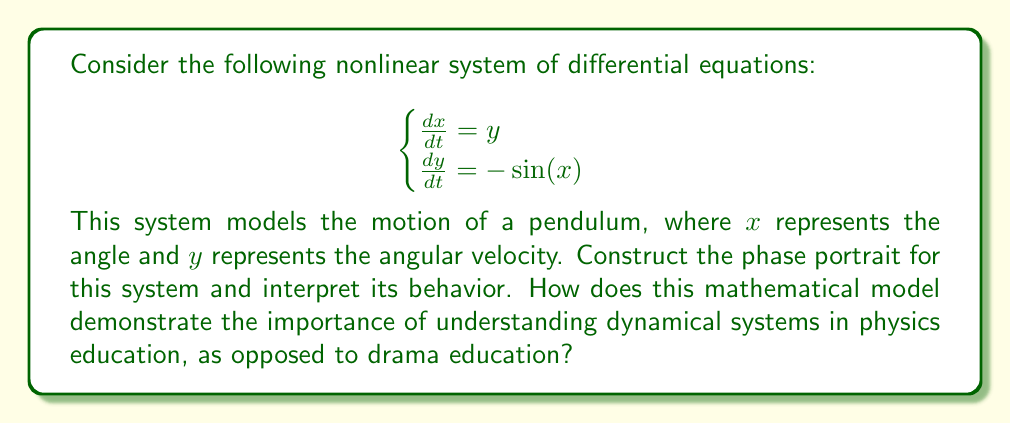Can you answer this question? To construct the phase portrait and interpret the system's behavior, we'll follow these steps:

1) Identify equilibrium points:
   Set $\frac{dx}{dt} = 0$ and $\frac{dy}{dt} = 0$
   $y = 0$ and $-\sin(x) = 0$
   Equilibrium points are $(n\pi, 0)$ where $n$ is an integer.

2) Linearize the system around equilibrium points:
   For $(0, 0)$ and $(2\pi, 0)$: 
   $$J = \begin{bmatrix}
   0 & 1 \\
   -\cos(0) & 0
   \end{bmatrix} = \begin{bmatrix}
   0 & 1 \\
   -1 & 0
   \end{bmatrix}$$
   Eigenvalues: $\lambda = \pm i$, indicating centers.

   For $(\pi, 0)$:
   $$J = \begin{bmatrix}
   0 & 1 \\
   -\cos(\pi) & 0
   \end{bmatrix} = \begin{bmatrix}
   0 & 1 \\
   1 & 0
   \end{bmatrix}$$
   Eigenvalues: $\lambda = \pm 1$, indicating a saddle point.

3) Sketch the phase portrait:
   [asy]
   import graph;
   size(200,200);
   
   void arrow(pair A, pair B, pen p=currentpen)
   {
     draw(A--B,p,Arrow(TeXHead));
   }
   
   for(int i=-2; i<=2; ++i) {
     draw((i*pi,-3)--(i*pi,3),gray);
   }
   
   for(real y=-3; y<=3; y+=0.5) {
     arrow((-2pi,y), (-1.9pi,y+0.1*sin(-1.9pi)), blue);
     arrow((0,y), (0.1,y+0.1*sin(0.1)), blue);
     arrow((2pi,y), (2.1pi,y+0.1*sin(2.1pi)), blue);
   }
   
   for(real x=-2pi; x<=2pi; x+=0.2) {
     arrow((x,-3), (x+0.1,-2.9), blue);
     arrow((x,0), (x+0.1,0.1), blue);
     arrow((x,3), (x+0.1,3.1), blue);
   }
   
   dot((-2pi,0)); dot((0,0)); dot((2pi,0)); dot((pi,0)); dot((-pi,0));
   label("$(-2\pi,0)$", (-2pi,0), S);
   label("$(0,0)$", (0,0), S);
   label("$(2\pi,0)$", (2pi,0), S);
   label("$(\pi,0)$", (pi,0), N);
   label("$(-\pi,0)$", (-pi,0), N);
   
   draw((-2pi,-2)..(-pi,0)..(0,-2), green);
   draw((-2pi,2)..(-pi,0)..(0,2), green);
   draw((0,-2)..(pi,0)..(2pi,-2), green);
   draw((0,2)..(pi,0)..(2pi,2), green);
   [/asy]

4) Interpret the behavior:
   - Centers at $(2n\pi, 0)$ represent oscillations of the pendulum.
   - Saddle points at $((2n+1)\pi, 0)$ represent unstable equilibrium (pendulum pointing upward).
   - Closed orbits around centers represent periodic motion (swinging back and forth).
   - Heteroclinic orbits connecting saddle points represent the pendulum making a full rotation.

This model demonstrates the importance of understanding dynamical systems in physics education by showing how mathematical analysis can predict and explain real-world phenomena, such as the motion of a pendulum. It illustrates concepts like stability, periodicity, and phase space, which are crucial in many areas of physics and engineering. Unlike drama education, this mathematical approach provides quantitative insights and predictive power, essential for technological advancement and scientific understanding.
Answer: The phase portrait shows centers at $(2n\pi, 0)$ and saddle points at $((2n+1)\pi, 0)$, with closed orbits around centers and heteroclinic orbits connecting saddle points, representing oscillatory and rotational motion of a pendulum. 